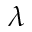<formula> <loc_0><loc_0><loc_500><loc_500>\lambda</formula> 